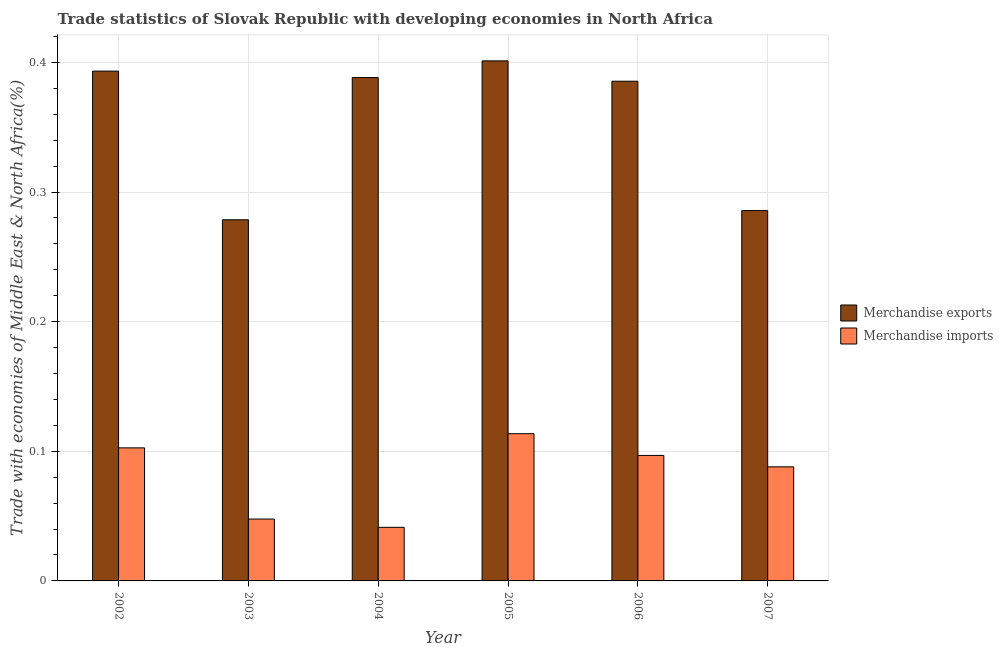How many different coloured bars are there?
Offer a very short reply. 2. How many groups of bars are there?
Offer a very short reply. 6. Are the number of bars per tick equal to the number of legend labels?
Give a very brief answer. Yes. Are the number of bars on each tick of the X-axis equal?
Offer a very short reply. Yes. What is the label of the 1st group of bars from the left?
Offer a very short reply. 2002. What is the merchandise exports in 2004?
Your response must be concise. 0.39. Across all years, what is the maximum merchandise imports?
Give a very brief answer. 0.11. Across all years, what is the minimum merchandise exports?
Keep it short and to the point. 0.28. What is the total merchandise imports in the graph?
Your response must be concise. 0.49. What is the difference between the merchandise exports in 2002 and that in 2007?
Offer a very short reply. 0.11. What is the difference between the merchandise exports in 2005 and the merchandise imports in 2002?
Your answer should be compact. 0.01. What is the average merchandise imports per year?
Offer a very short reply. 0.08. In the year 2007, what is the difference between the merchandise exports and merchandise imports?
Offer a terse response. 0. What is the ratio of the merchandise imports in 2006 to that in 2007?
Keep it short and to the point. 1.1. Is the difference between the merchandise exports in 2002 and 2005 greater than the difference between the merchandise imports in 2002 and 2005?
Provide a succinct answer. No. What is the difference between the highest and the second highest merchandise imports?
Your answer should be compact. 0.01. What is the difference between the highest and the lowest merchandise imports?
Your answer should be very brief. 0.07. In how many years, is the merchandise imports greater than the average merchandise imports taken over all years?
Make the answer very short. 4. Is the sum of the merchandise exports in 2003 and 2005 greater than the maximum merchandise imports across all years?
Give a very brief answer. Yes. What does the 1st bar from the left in 2007 represents?
Provide a succinct answer. Merchandise exports. What does the 2nd bar from the right in 2005 represents?
Your answer should be very brief. Merchandise exports. How many years are there in the graph?
Provide a short and direct response. 6. What is the difference between two consecutive major ticks on the Y-axis?
Give a very brief answer. 0.1. Are the values on the major ticks of Y-axis written in scientific E-notation?
Ensure brevity in your answer.  No. Does the graph contain any zero values?
Make the answer very short. No. How many legend labels are there?
Offer a terse response. 2. What is the title of the graph?
Give a very brief answer. Trade statistics of Slovak Republic with developing economies in North Africa. Does "Under-5(female)" appear as one of the legend labels in the graph?
Provide a succinct answer. No. What is the label or title of the X-axis?
Your answer should be compact. Year. What is the label or title of the Y-axis?
Keep it short and to the point. Trade with economies of Middle East & North Africa(%). What is the Trade with economies of Middle East & North Africa(%) of Merchandise exports in 2002?
Your answer should be compact. 0.39. What is the Trade with economies of Middle East & North Africa(%) of Merchandise imports in 2002?
Your answer should be very brief. 0.1. What is the Trade with economies of Middle East & North Africa(%) in Merchandise exports in 2003?
Your response must be concise. 0.28. What is the Trade with economies of Middle East & North Africa(%) of Merchandise imports in 2003?
Provide a succinct answer. 0.05. What is the Trade with economies of Middle East & North Africa(%) in Merchandise exports in 2004?
Your answer should be very brief. 0.39. What is the Trade with economies of Middle East & North Africa(%) in Merchandise imports in 2004?
Offer a terse response. 0.04. What is the Trade with economies of Middle East & North Africa(%) in Merchandise exports in 2005?
Your response must be concise. 0.4. What is the Trade with economies of Middle East & North Africa(%) of Merchandise imports in 2005?
Provide a succinct answer. 0.11. What is the Trade with economies of Middle East & North Africa(%) of Merchandise exports in 2006?
Make the answer very short. 0.39. What is the Trade with economies of Middle East & North Africa(%) in Merchandise imports in 2006?
Keep it short and to the point. 0.1. What is the Trade with economies of Middle East & North Africa(%) in Merchandise exports in 2007?
Give a very brief answer. 0.29. What is the Trade with economies of Middle East & North Africa(%) in Merchandise imports in 2007?
Offer a very short reply. 0.09. Across all years, what is the maximum Trade with economies of Middle East & North Africa(%) in Merchandise exports?
Your answer should be compact. 0.4. Across all years, what is the maximum Trade with economies of Middle East & North Africa(%) in Merchandise imports?
Provide a short and direct response. 0.11. Across all years, what is the minimum Trade with economies of Middle East & North Africa(%) in Merchandise exports?
Give a very brief answer. 0.28. Across all years, what is the minimum Trade with economies of Middle East & North Africa(%) of Merchandise imports?
Offer a very short reply. 0.04. What is the total Trade with economies of Middle East & North Africa(%) of Merchandise exports in the graph?
Offer a terse response. 2.13. What is the total Trade with economies of Middle East & North Africa(%) in Merchandise imports in the graph?
Ensure brevity in your answer.  0.49. What is the difference between the Trade with economies of Middle East & North Africa(%) in Merchandise exports in 2002 and that in 2003?
Keep it short and to the point. 0.11. What is the difference between the Trade with economies of Middle East & North Africa(%) in Merchandise imports in 2002 and that in 2003?
Offer a very short reply. 0.05. What is the difference between the Trade with economies of Middle East & North Africa(%) in Merchandise exports in 2002 and that in 2004?
Keep it short and to the point. 0.01. What is the difference between the Trade with economies of Middle East & North Africa(%) in Merchandise imports in 2002 and that in 2004?
Your answer should be very brief. 0.06. What is the difference between the Trade with economies of Middle East & North Africa(%) in Merchandise exports in 2002 and that in 2005?
Keep it short and to the point. -0.01. What is the difference between the Trade with economies of Middle East & North Africa(%) of Merchandise imports in 2002 and that in 2005?
Ensure brevity in your answer.  -0.01. What is the difference between the Trade with economies of Middle East & North Africa(%) in Merchandise exports in 2002 and that in 2006?
Ensure brevity in your answer.  0.01. What is the difference between the Trade with economies of Middle East & North Africa(%) of Merchandise imports in 2002 and that in 2006?
Your answer should be compact. 0.01. What is the difference between the Trade with economies of Middle East & North Africa(%) in Merchandise exports in 2002 and that in 2007?
Offer a terse response. 0.11. What is the difference between the Trade with economies of Middle East & North Africa(%) of Merchandise imports in 2002 and that in 2007?
Make the answer very short. 0.01. What is the difference between the Trade with economies of Middle East & North Africa(%) in Merchandise exports in 2003 and that in 2004?
Offer a very short reply. -0.11. What is the difference between the Trade with economies of Middle East & North Africa(%) in Merchandise imports in 2003 and that in 2004?
Ensure brevity in your answer.  0.01. What is the difference between the Trade with economies of Middle East & North Africa(%) of Merchandise exports in 2003 and that in 2005?
Provide a short and direct response. -0.12. What is the difference between the Trade with economies of Middle East & North Africa(%) in Merchandise imports in 2003 and that in 2005?
Your answer should be very brief. -0.07. What is the difference between the Trade with economies of Middle East & North Africa(%) in Merchandise exports in 2003 and that in 2006?
Provide a succinct answer. -0.11. What is the difference between the Trade with economies of Middle East & North Africa(%) of Merchandise imports in 2003 and that in 2006?
Provide a succinct answer. -0.05. What is the difference between the Trade with economies of Middle East & North Africa(%) in Merchandise exports in 2003 and that in 2007?
Provide a short and direct response. -0.01. What is the difference between the Trade with economies of Middle East & North Africa(%) in Merchandise imports in 2003 and that in 2007?
Provide a succinct answer. -0.04. What is the difference between the Trade with economies of Middle East & North Africa(%) in Merchandise exports in 2004 and that in 2005?
Give a very brief answer. -0.01. What is the difference between the Trade with economies of Middle East & North Africa(%) of Merchandise imports in 2004 and that in 2005?
Give a very brief answer. -0.07. What is the difference between the Trade with economies of Middle East & North Africa(%) of Merchandise exports in 2004 and that in 2006?
Keep it short and to the point. 0. What is the difference between the Trade with economies of Middle East & North Africa(%) in Merchandise imports in 2004 and that in 2006?
Provide a succinct answer. -0.06. What is the difference between the Trade with economies of Middle East & North Africa(%) in Merchandise exports in 2004 and that in 2007?
Offer a terse response. 0.1. What is the difference between the Trade with economies of Middle East & North Africa(%) of Merchandise imports in 2004 and that in 2007?
Make the answer very short. -0.05. What is the difference between the Trade with economies of Middle East & North Africa(%) of Merchandise exports in 2005 and that in 2006?
Make the answer very short. 0.02. What is the difference between the Trade with economies of Middle East & North Africa(%) of Merchandise imports in 2005 and that in 2006?
Give a very brief answer. 0.02. What is the difference between the Trade with economies of Middle East & North Africa(%) in Merchandise exports in 2005 and that in 2007?
Offer a very short reply. 0.12. What is the difference between the Trade with economies of Middle East & North Africa(%) in Merchandise imports in 2005 and that in 2007?
Ensure brevity in your answer.  0.03. What is the difference between the Trade with economies of Middle East & North Africa(%) in Merchandise exports in 2006 and that in 2007?
Offer a very short reply. 0.1. What is the difference between the Trade with economies of Middle East & North Africa(%) in Merchandise imports in 2006 and that in 2007?
Make the answer very short. 0.01. What is the difference between the Trade with economies of Middle East & North Africa(%) in Merchandise exports in 2002 and the Trade with economies of Middle East & North Africa(%) in Merchandise imports in 2003?
Ensure brevity in your answer.  0.35. What is the difference between the Trade with economies of Middle East & North Africa(%) of Merchandise exports in 2002 and the Trade with economies of Middle East & North Africa(%) of Merchandise imports in 2004?
Make the answer very short. 0.35. What is the difference between the Trade with economies of Middle East & North Africa(%) in Merchandise exports in 2002 and the Trade with economies of Middle East & North Africa(%) in Merchandise imports in 2005?
Your answer should be very brief. 0.28. What is the difference between the Trade with economies of Middle East & North Africa(%) of Merchandise exports in 2002 and the Trade with economies of Middle East & North Africa(%) of Merchandise imports in 2006?
Make the answer very short. 0.3. What is the difference between the Trade with economies of Middle East & North Africa(%) of Merchandise exports in 2002 and the Trade with economies of Middle East & North Africa(%) of Merchandise imports in 2007?
Offer a terse response. 0.31. What is the difference between the Trade with economies of Middle East & North Africa(%) in Merchandise exports in 2003 and the Trade with economies of Middle East & North Africa(%) in Merchandise imports in 2004?
Make the answer very short. 0.24. What is the difference between the Trade with economies of Middle East & North Africa(%) of Merchandise exports in 2003 and the Trade with economies of Middle East & North Africa(%) of Merchandise imports in 2005?
Offer a very short reply. 0.17. What is the difference between the Trade with economies of Middle East & North Africa(%) of Merchandise exports in 2003 and the Trade with economies of Middle East & North Africa(%) of Merchandise imports in 2006?
Your response must be concise. 0.18. What is the difference between the Trade with economies of Middle East & North Africa(%) in Merchandise exports in 2003 and the Trade with economies of Middle East & North Africa(%) in Merchandise imports in 2007?
Give a very brief answer. 0.19. What is the difference between the Trade with economies of Middle East & North Africa(%) in Merchandise exports in 2004 and the Trade with economies of Middle East & North Africa(%) in Merchandise imports in 2005?
Ensure brevity in your answer.  0.27. What is the difference between the Trade with economies of Middle East & North Africa(%) of Merchandise exports in 2004 and the Trade with economies of Middle East & North Africa(%) of Merchandise imports in 2006?
Give a very brief answer. 0.29. What is the difference between the Trade with economies of Middle East & North Africa(%) of Merchandise exports in 2004 and the Trade with economies of Middle East & North Africa(%) of Merchandise imports in 2007?
Give a very brief answer. 0.3. What is the difference between the Trade with economies of Middle East & North Africa(%) in Merchandise exports in 2005 and the Trade with economies of Middle East & North Africa(%) in Merchandise imports in 2006?
Your response must be concise. 0.3. What is the difference between the Trade with economies of Middle East & North Africa(%) of Merchandise exports in 2005 and the Trade with economies of Middle East & North Africa(%) of Merchandise imports in 2007?
Keep it short and to the point. 0.31. What is the difference between the Trade with economies of Middle East & North Africa(%) in Merchandise exports in 2006 and the Trade with economies of Middle East & North Africa(%) in Merchandise imports in 2007?
Give a very brief answer. 0.3. What is the average Trade with economies of Middle East & North Africa(%) of Merchandise exports per year?
Offer a very short reply. 0.36. What is the average Trade with economies of Middle East & North Africa(%) in Merchandise imports per year?
Keep it short and to the point. 0.08. In the year 2002, what is the difference between the Trade with economies of Middle East & North Africa(%) of Merchandise exports and Trade with economies of Middle East & North Africa(%) of Merchandise imports?
Offer a terse response. 0.29. In the year 2003, what is the difference between the Trade with economies of Middle East & North Africa(%) in Merchandise exports and Trade with economies of Middle East & North Africa(%) in Merchandise imports?
Offer a very short reply. 0.23. In the year 2004, what is the difference between the Trade with economies of Middle East & North Africa(%) in Merchandise exports and Trade with economies of Middle East & North Africa(%) in Merchandise imports?
Keep it short and to the point. 0.35. In the year 2005, what is the difference between the Trade with economies of Middle East & North Africa(%) of Merchandise exports and Trade with economies of Middle East & North Africa(%) of Merchandise imports?
Offer a terse response. 0.29. In the year 2006, what is the difference between the Trade with economies of Middle East & North Africa(%) in Merchandise exports and Trade with economies of Middle East & North Africa(%) in Merchandise imports?
Provide a succinct answer. 0.29. In the year 2007, what is the difference between the Trade with economies of Middle East & North Africa(%) of Merchandise exports and Trade with economies of Middle East & North Africa(%) of Merchandise imports?
Provide a succinct answer. 0.2. What is the ratio of the Trade with economies of Middle East & North Africa(%) in Merchandise exports in 2002 to that in 2003?
Ensure brevity in your answer.  1.41. What is the ratio of the Trade with economies of Middle East & North Africa(%) in Merchandise imports in 2002 to that in 2003?
Offer a very short reply. 2.15. What is the ratio of the Trade with economies of Middle East & North Africa(%) of Merchandise exports in 2002 to that in 2004?
Give a very brief answer. 1.01. What is the ratio of the Trade with economies of Middle East & North Africa(%) in Merchandise imports in 2002 to that in 2004?
Make the answer very short. 2.48. What is the ratio of the Trade with economies of Middle East & North Africa(%) of Merchandise exports in 2002 to that in 2005?
Your response must be concise. 0.98. What is the ratio of the Trade with economies of Middle East & North Africa(%) in Merchandise imports in 2002 to that in 2005?
Give a very brief answer. 0.9. What is the ratio of the Trade with economies of Middle East & North Africa(%) in Merchandise exports in 2002 to that in 2006?
Your response must be concise. 1.02. What is the ratio of the Trade with economies of Middle East & North Africa(%) in Merchandise imports in 2002 to that in 2006?
Keep it short and to the point. 1.06. What is the ratio of the Trade with economies of Middle East & North Africa(%) in Merchandise exports in 2002 to that in 2007?
Offer a very short reply. 1.38. What is the ratio of the Trade with economies of Middle East & North Africa(%) in Merchandise imports in 2002 to that in 2007?
Provide a short and direct response. 1.17. What is the ratio of the Trade with economies of Middle East & North Africa(%) in Merchandise exports in 2003 to that in 2004?
Offer a very short reply. 0.72. What is the ratio of the Trade with economies of Middle East & North Africa(%) in Merchandise imports in 2003 to that in 2004?
Your answer should be compact. 1.15. What is the ratio of the Trade with economies of Middle East & North Africa(%) in Merchandise exports in 2003 to that in 2005?
Offer a terse response. 0.69. What is the ratio of the Trade with economies of Middle East & North Africa(%) of Merchandise imports in 2003 to that in 2005?
Ensure brevity in your answer.  0.42. What is the ratio of the Trade with economies of Middle East & North Africa(%) of Merchandise exports in 2003 to that in 2006?
Ensure brevity in your answer.  0.72. What is the ratio of the Trade with economies of Middle East & North Africa(%) in Merchandise imports in 2003 to that in 2006?
Your answer should be very brief. 0.49. What is the ratio of the Trade with economies of Middle East & North Africa(%) in Merchandise exports in 2003 to that in 2007?
Provide a short and direct response. 0.98. What is the ratio of the Trade with economies of Middle East & North Africa(%) of Merchandise imports in 2003 to that in 2007?
Your answer should be very brief. 0.54. What is the ratio of the Trade with economies of Middle East & North Africa(%) of Merchandise exports in 2004 to that in 2005?
Offer a very short reply. 0.97. What is the ratio of the Trade with economies of Middle East & North Africa(%) in Merchandise imports in 2004 to that in 2005?
Make the answer very short. 0.36. What is the ratio of the Trade with economies of Middle East & North Africa(%) of Merchandise exports in 2004 to that in 2006?
Make the answer very short. 1.01. What is the ratio of the Trade with economies of Middle East & North Africa(%) of Merchandise imports in 2004 to that in 2006?
Your response must be concise. 0.43. What is the ratio of the Trade with economies of Middle East & North Africa(%) of Merchandise exports in 2004 to that in 2007?
Provide a short and direct response. 1.36. What is the ratio of the Trade with economies of Middle East & North Africa(%) in Merchandise imports in 2004 to that in 2007?
Your response must be concise. 0.47. What is the ratio of the Trade with economies of Middle East & North Africa(%) of Merchandise exports in 2005 to that in 2006?
Offer a terse response. 1.04. What is the ratio of the Trade with economies of Middle East & North Africa(%) of Merchandise imports in 2005 to that in 2006?
Your answer should be compact. 1.17. What is the ratio of the Trade with economies of Middle East & North Africa(%) in Merchandise exports in 2005 to that in 2007?
Your answer should be compact. 1.4. What is the ratio of the Trade with economies of Middle East & North Africa(%) in Merchandise imports in 2005 to that in 2007?
Provide a short and direct response. 1.29. What is the ratio of the Trade with economies of Middle East & North Africa(%) of Merchandise exports in 2006 to that in 2007?
Provide a succinct answer. 1.35. What is the ratio of the Trade with economies of Middle East & North Africa(%) of Merchandise imports in 2006 to that in 2007?
Offer a terse response. 1.1. What is the difference between the highest and the second highest Trade with economies of Middle East & North Africa(%) in Merchandise exports?
Ensure brevity in your answer.  0.01. What is the difference between the highest and the second highest Trade with economies of Middle East & North Africa(%) of Merchandise imports?
Keep it short and to the point. 0.01. What is the difference between the highest and the lowest Trade with economies of Middle East & North Africa(%) in Merchandise exports?
Give a very brief answer. 0.12. What is the difference between the highest and the lowest Trade with economies of Middle East & North Africa(%) of Merchandise imports?
Make the answer very short. 0.07. 